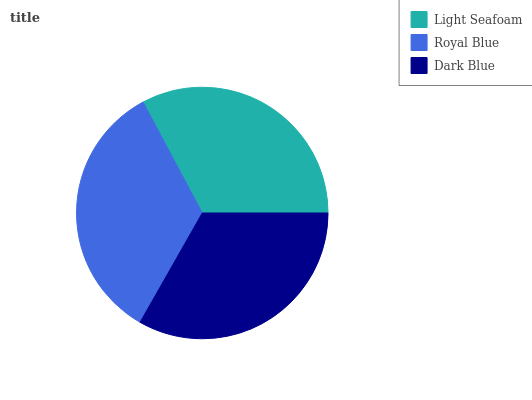Is Light Seafoam the minimum?
Answer yes or no. Yes. Is Royal Blue the maximum?
Answer yes or no. Yes. Is Dark Blue the minimum?
Answer yes or no. No. Is Dark Blue the maximum?
Answer yes or no. No. Is Royal Blue greater than Dark Blue?
Answer yes or no. Yes. Is Dark Blue less than Royal Blue?
Answer yes or no. Yes. Is Dark Blue greater than Royal Blue?
Answer yes or no. No. Is Royal Blue less than Dark Blue?
Answer yes or no. No. Is Dark Blue the high median?
Answer yes or no. Yes. Is Dark Blue the low median?
Answer yes or no. Yes. Is Light Seafoam the high median?
Answer yes or no. No. Is Royal Blue the low median?
Answer yes or no. No. 